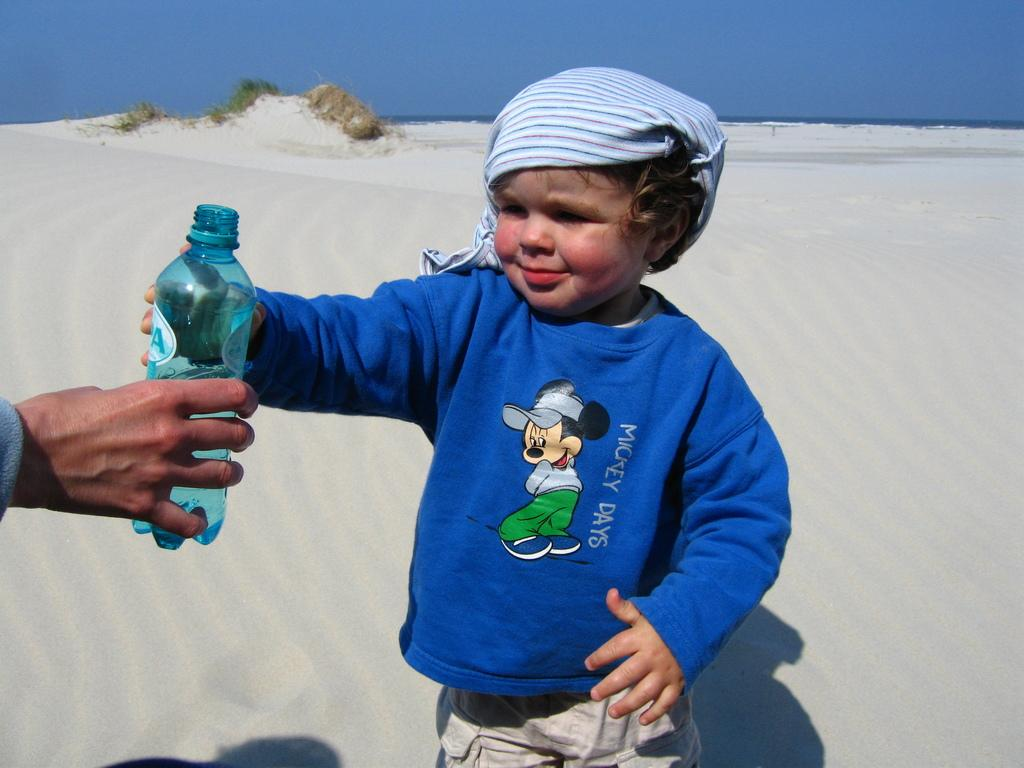What type of environment is shown in the image? The image depicts a desert. Can you describe the people in the image? There is a boy standing in the image. What is the boy doing in the image? The boy is taking a bottle from another person's hand. What type of button can be seen on the boy's shirt in the image? There is no button visible on the boy's shirt in the image. Is there any rain visible in the image? No, there is no rain visible in the image, as it depicts a desert environment. 